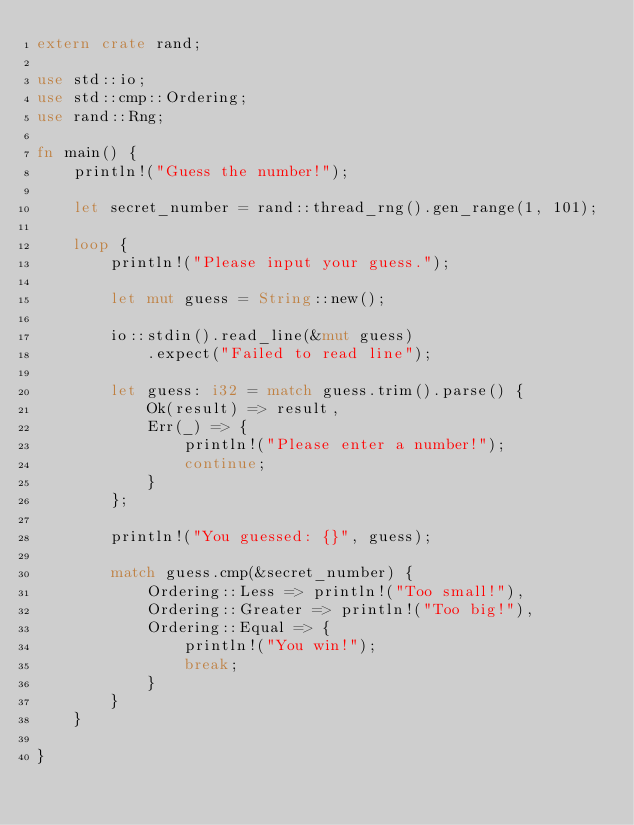<code> <loc_0><loc_0><loc_500><loc_500><_Rust_>extern crate rand;

use std::io;
use std::cmp::Ordering;
use rand::Rng;

fn main() {
    println!("Guess the number!");

    let secret_number = rand::thread_rng().gen_range(1, 101);

    loop {
        println!("Please input your guess.");

        let mut guess = String::new();

        io::stdin().read_line(&mut guess)
            .expect("Failed to read line");

        let guess: i32 = match guess.trim().parse() {
            Ok(result) => result,
            Err(_) => {
                println!("Please enter a number!");
                continue;
            }
        };

        println!("You guessed: {}", guess);

        match guess.cmp(&secret_number) {
            Ordering::Less => println!("Too small!"),
            Ordering::Greater => println!("Too big!"),
            Ordering::Equal => {
                println!("You win!");
                break;
            }
        }
    }

}</code> 